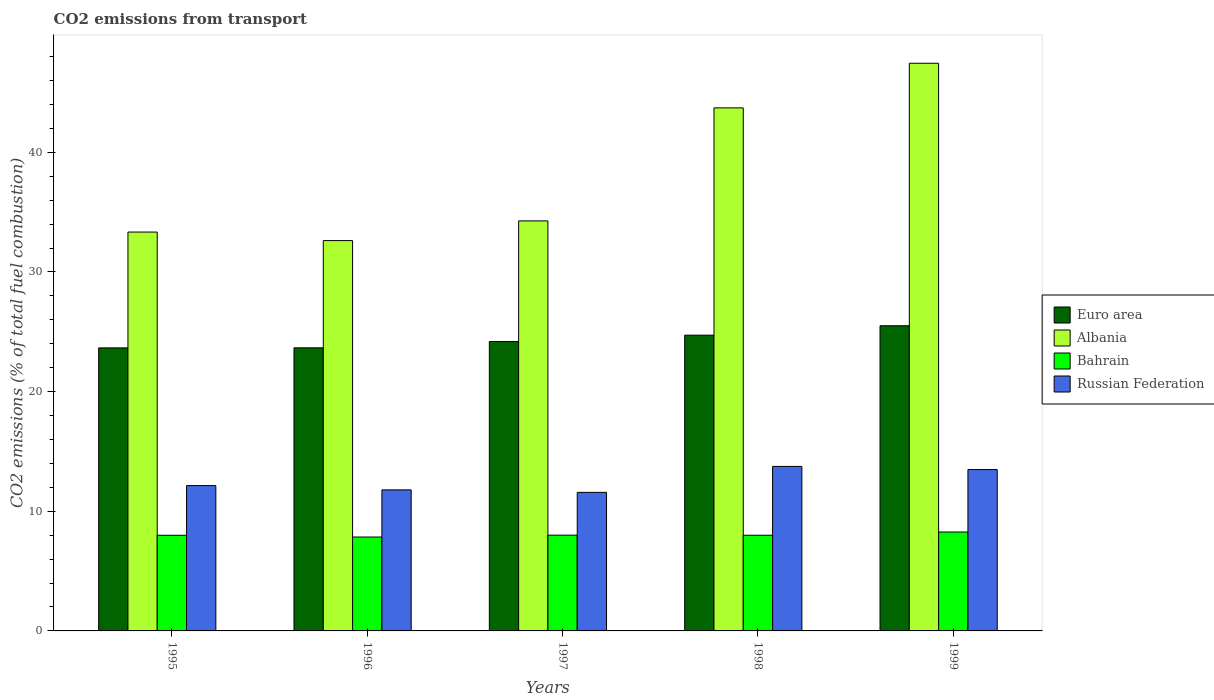How many different coloured bars are there?
Offer a terse response. 4. How many groups of bars are there?
Offer a terse response. 5. How many bars are there on the 5th tick from the left?
Ensure brevity in your answer.  4. What is the total CO2 emitted in Albania in 1997?
Keep it short and to the point. 34.27. Across all years, what is the maximum total CO2 emitted in Albania?
Your answer should be compact. 47.44. Across all years, what is the minimum total CO2 emitted in Bahrain?
Offer a terse response. 7.85. In which year was the total CO2 emitted in Albania maximum?
Keep it short and to the point. 1999. In which year was the total CO2 emitted in Bahrain minimum?
Offer a terse response. 1996. What is the total total CO2 emitted in Euro area in the graph?
Offer a very short reply. 121.72. What is the difference between the total CO2 emitted in Albania in 1996 and that in 1998?
Offer a terse response. -11.09. What is the difference between the total CO2 emitted in Euro area in 1997 and the total CO2 emitted in Russian Federation in 1995?
Keep it short and to the point. 12.04. What is the average total CO2 emitted in Russian Federation per year?
Keep it short and to the point. 12.55. In the year 1998, what is the difference between the total CO2 emitted in Euro area and total CO2 emitted in Russian Federation?
Your answer should be compact. 10.97. What is the ratio of the total CO2 emitted in Bahrain in 1997 to that in 1998?
Offer a very short reply. 1. Is the difference between the total CO2 emitted in Euro area in 1997 and 1999 greater than the difference between the total CO2 emitted in Russian Federation in 1997 and 1999?
Give a very brief answer. Yes. What is the difference between the highest and the second highest total CO2 emitted in Bahrain?
Your answer should be compact. 0.26. What is the difference between the highest and the lowest total CO2 emitted in Albania?
Keep it short and to the point. 14.82. In how many years, is the total CO2 emitted in Russian Federation greater than the average total CO2 emitted in Russian Federation taken over all years?
Offer a terse response. 2. Is the sum of the total CO2 emitted in Bahrain in 1996 and 1997 greater than the maximum total CO2 emitted in Albania across all years?
Give a very brief answer. No. What does the 1st bar from the left in 1998 represents?
Offer a terse response. Euro area. Is it the case that in every year, the sum of the total CO2 emitted in Bahrain and total CO2 emitted in Euro area is greater than the total CO2 emitted in Russian Federation?
Keep it short and to the point. Yes. How many bars are there?
Your response must be concise. 20. Are all the bars in the graph horizontal?
Provide a succinct answer. No. Does the graph contain grids?
Ensure brevity in your answer.  No. Where does the legend appear in the graph?
Ensure brevity in your answer.  Center right. How many legend labels are there?
Provide a short and direct response. 4. How are the legend labels stacked?
Give a very brief answer. Vertical. What is the title of the graph?
Your answer should be very brief. CO2 emissions from transport. Does "French Polynesia" appear as one of the legend labels in the graph?
Make the answer very short. No. What is the label or title of the Y-axis?
Offer a terse response. CO2 emissions (% of total fuel combustion). What is the CO2 emissions (% of total fuel combustion) in Euro area in 1995?
Make the answer very short. 23.65. What is the CO2 emissions (% of total fuel combustion) in Albania in 1995?
Your answer should be very brief. 33.33. What is the CO2 emissions (% of total fuel combustion) in Bahrain in 1995?
Your answer should be compact. 7.99. What is the CO2 emissions (% of total fuel combustion) in Russian Federation in 1995?
Your answer should be compact. 12.15. What is the CO2 emissions (% of total fuel combustion) of Euro area in 1996?
Provide a short and direct response. 23.66. What is the CO2 emissions (% of total fuel combustion) in Albania in 1996?
Keep it short and to the point. 32.62. What is the CO2 emissions (% of total fuel combustion) of Bahrain in 1996?
Offer a terse response. 7.85. What is the CO2 emissions (% of total fuel combustion) of Russian Federation in 1996?
Offer a terse response. 11.79. What is the CO2 emissions (% of total fuel combustion) of Euro area in 1997?
Give a very brief answer. 24.19. What is the CO2 emissions (% of total fuel combustion) in Albania in 1997?
Your answer should be compact. 34.27. What is the CO2 emissions (% of total fuel combustion) of Bahrain in 1997?
Provide a short and direct response. 8. What is the CO2 emissions (% of total fuel combustion) in Russian Federation in 1997?
Provide a short and direct response. 11.58. What is the CO2 emissions (% of total fuel combustion) of Euro area in 1998?
Provide a succinct answer. 24.72. What is the CO2 emissions (% of total fuel combustion) in Albania in 1998?
Your answer should be very brief. 43.71. What is the CO2 emissions (% of total fuel combustion) of Bahrain in 1998?
Your answer should be compact. 8. What is the CO2 emissions (% of total fuel combustion) in Russian Federation in 1998?
Keep it short and to the point. 13.75. What is the CO2 emissions (% of total fuel combustion) of Euro area in 1999?
Offer a very short reply. 25.5. What is the CO2 emissions (% of total fuel combustion) in Albania in 1999?
Provide a succinct answer. 47.44. What is the CO2 emissions (% of total fuel combustion) of Bahrain in 1999?
Make the answer very short. 8.27. What is the CO2 emissions (% of total fuel combustion) of Russian Federation in 1999?
Provide a succinct answer. 13.49. Across all years, what is the maximum CO2 emissions (% of total fuel combustion) of Euro area?
Provide a succinct answer. 25.5. Across all years, what is the maximum CO2 emissions (% of total fuel combustion) in Albania?
Give a very brief answer. 47.44. Across all years, what is the maximum CO2 emissions (% of total fuel combustion) in Bahrain?
Give a very brief answer. 8.27. Across all years, what is the maximum CO2 emissions (% of total fuel combustion) of Russian Federation?
Keep it short and to the point. 13.75. Across all years, what is the minimum CO2 emissions (% of total fuel combustion) in Euro area?
Your response must be concise. 23.65. Across all years, what is the minimum CO2 emissions (% of total fuel combustion) of Albania?
Offer a very short reply. 32.62. Across all years, what is the minimum CO2 emissions (% of total fuel combustion) in Bahrain?
Keep it short and to the point. 7.85. Across all years, what is the minimum CO2 emissions (% of total fuel combustion) of Russian Federation?
Your answer should be very brief. 11.58. What is the total CO2 emissions (% of total fuel combustion) in Euro area in the graph?
Your answer should be very brief. 121.72. What is the total CO2 emissions (% of total fuel combustion) of Albania in the graph?
Give a very brief answer. 191.37. What is the total CO2 emissions (% of total fuel combustion) of Bahrain in the graph?
Offer a very short reply. 40.1. What is the total CO2 emissions (% of total fuel combustion) of Russian Federation in the graph?
Provide a short and direct response. 62.75. What is the difference between the CO2 emissions (% of total fuel combustion) in Euro area in 1995 and that in 1996?
Ensure brevity in your answer.  -0.01. What is the difference between the CO2 emissions (% of total fuel combustion) of Albania in 1995 and that in 1996?
Offer a very short reply. 0.71. What is the difference between the CO2 emissions (% of total fuel combustion) of Bahrain in 1995 and that in 1996?
Offer a very short reply. 0.15. What is the difference between the CO2 emissions (% of total fuel combustion) of Russian Federation in 1995 and that in 1996?
Your answer should be very brief. 0.36. What is the difference between the CO2 emissions (% of total fuel combustion) in Euro area in 1995 and that in 1997?
Offer a terse response. -0.53. What is the difference between the CO2 emissions (% of total fuel combustion) of Albania in 1995 and that in 1997?
Offer a very short reply. -0.93. What is the difference between the CO2 emissions (% of total fuel combustion) in Bahrain in 1995 and that in 1997?
Provide a short and direct response. -0.01. What is the difference between the CO2 emissions (% of total fuel combustion) of Russian Federation in 1995 and that in 1997?
Give a very brief answer. 0.57. What is the difference between the CO2 emissions (% of total fuel combustion) in Euro area in 1995 and that in 1998?
Offer a very short reply. -1.06. What is the difference between the CO2 emissions (% of total fuel combustion) in Albania in 1995 and that in 1998?
Your response must be concise. -10.38. What is the difference between the CO2 emissions (% of total fuel combustion) in Bahrain in 1995 and that in 1998?
Give a very brief answer. -0. What is the difference between the CO2 emissions (% of total fuel combustion) of Russian Federation in 1995 and that in 1998?
Your response must be concise. -1.6. What is the difference between the CO2 emissions (% of total fuel combustion) of Euro area in 1995 and that in 1999?
Keep it short and to the point. -1.85. What is the difference between the CO2 emissions (% of total fuel combustion) of Albania in 1995 and that in 1999?
Your answer should be very brief. -14.11. What is the difference between the CO2 emissions (% of total fuel combustion) of Bahrain in 1995 and that in 1999?
Give a very brief answer. -0.27. What is the difference between the CO2 emissions (% of total fuel combustion) of Russian Federation in 1995 and that in 1999?
Keep it short and to the point. -1.34. What is the difference between the CO2 emissions (% of total fuel combustion) of Euro area in 1996 and that in 1997?
Keep it short and to the point. -0.53. What is the difference between the CO2 emissions (% of total fuel combustion) in Albania in 1996 and that in 1997?
Your response must be concise. -1.65. What is the difference between the CO2 emissions (% of total fuel combustion) of Bahrain in 1996 and that in 1997?
Ensure brevity in your answer.  -0.16. What is the difference between the CO2 emissions (% of total fuel combustion) of Russian Federation in 1996 and that in 1997?
Provide a short and direct response. 0.21. What is the difference between the CO2 emissions (% of total fuel combustion) in Euro area in 1996 and that in 1998?
Ensure brevity in your answer.  -1.06. What is the difference between the CO2 emissions (% of total fuel combustion) in Albania in 1996 and that in 1998?
Your response must be concise. -11.09. What is the difference between the CO2 emissions (% of total fuel combustion) of Bahrain in 1996 and that in 1998?
Keep it short and to the point. -0.15. What is the difference between the CO2 emissions (% of total fuel combustion) of Russian Federation in 1996 and that in 1998?
Offer a terse response. -1.96. What is the difference between the CO2 emissions (% of total fuel combustion) in Euro area in 1996 and that in 1999?
Offer a very short reply. -1.84. What is the difference between the CO2 emissions (% of total fuel combustion) in Albania in 1996 and that in 1999?
Offer a terse response. -14.82. What is the difference between the CO2 emissions (% of total fuel combustion) in Bahrain in 1996 and that in 1999?
Offer a terse response. -0.42. What is the difference between the CO2 emissions (% of total fuel combustion) in Russian Federation in 1996 and that in 1999?
Offer a terse response. -1.7. What is the difference between the CO2 emissions (% of total fuel combustion) of Euro area in 1997 and that in 1998?
Ensure brevity in your answer.  -0.53. What is the difference between the CO2 emissions (% of total fuel combustion) of Albania in 1997 and that in 1998?
Keep it short and to the point. -9.45. What is the difference between the CO2 emissions (% of total fuel combustion) in Bahrain in 1997 and that in 1998?
Offer a very short reply. 0.01. What is the difference between the CO2 emissions (% of total fuel combustion) in Russian Federation in 1997 and that in 1998?
Your answer should be compact. -2.17. What is the difference between the CO2 emissions (% of total fuel combustion) in Euro area in 1997 and that in 1999?
Your answer should be compact. -1.32. What is the difference between the CO2 emissions (% of total fuel combustion) of Albania in 1997 and that in 1999?
Offer a terse response. -13.17. What is the difference between the CO2 emissions (% of total fuel combustion) in Bahrain in 1997 and that in 1999?
Provide a short and direct response. -0.26. What is the difference between the CO2 emissions (% of total fuel combustion) in Russian Federation in 1997 and that in 1999?
Your answer should be compact. -1.91. What is the difference between the CO2 emissions (% of total fuel combustion) of Euro area in 1998 and that in 1999?
Provide a succinct answer. -0.79. What is the difference between the CO2 emissions (% of total fuel combustion) in Albania in 1998 and that in 1999?
Keep it short and to the point. -3.73. What is the difference between the CO2 emissions (% of total fuel combustion) in Bahrain in 1998 and that in 1999?
Your answer should be very brief. -0.27. What is the difference between the CO2 emissions (% of total fuel combustion) in Russian Federation in 1998 and that in 1999?
Give a very brief answer. 0.26. What is the difference between the CO2 emissions (% of total fuel combustion) of Euro area in 1995 and the CO2 emissions (% of total fuel combustion) of Albania in 1996?
Keep it short and to the point. -8.97. What is the difference between the CO2 emissions (% of total fuel combustion) of Euro area in 1995 and the CO2 emissions (% of total fuel combustion) of Bahrain in 1996?
Ensure brevity in your answer.  15.81. What is the difference between the CO2 emissions (% of total fuel combustion) in Euro area in 1995 and the CO2 emissions (% of total fuel combustion) in Russian Federation in 1996?
Ensure brevity in your answer.  11.87. What is the difference between the CO2 emissions (% of total fuel combustion) of Albania in 1995 and the CO2 emissions (% of total fuel combustion) of Bahrain in 1996?
Your answer should be compact. 25.49. What is the difference between the CO2 emissions (% of total fuel combustion) of Albania in 1995 and the CO2 emissions (% of total fuel combustion) of Russian Federation in 1996?
Provide a short and direct response. 21.55. What is the difference between the CO2 emissions (% of total fuel combustion) of Bahrain in 1995 and the CO2 emissions (% of total fuel combustion) of Russian Federation in 1996?
Your answer should be very brief. -3.79. What is the difference between the CO2 emissions (% of total fuel combustion) in Euro area in 1995 and the CO2 emissions (% of total fuel combustion) in Albania in 1997?
Keep it short and to the point. -10.61. What is the difference between the CO2 emissions (% of total fuel combustion) of Euro area in 1995 and the CO2 emissions (% of total fuel combustion) of Bahrain in 1997?
Offer a terse response. 15.65. What is the difference between the CO2 emissions (% of total fuel combustion) of Euro area in 1995 and the CO2 emissions (% of total fuel combustion) of Russian Federation in 1997?
Offer a very short reply. 12.08. What is the difference between the CO2 emissions (% of total fuel combustion) of Albania in 1995 and the CO2 emissions (% of total fuel combustion) of Bahrain in 1997?
Provide a succinct answer. 25.33. What is the difference between the CO2 emissions (% of total fuel combustion) in Albania in 1995 and the CO2 emissions (% of total fuel combustion) in Russian Federation in 1997?
Offer a very short reply. 21.75. What is the difference between the CO2 emissions (% of total fuel combustion) in Bahrain in 1995 and the CO2 emissions (% of total fuel combustion) in Russian Federation in 1997?
Offer a terse response. -3.59. What is the difference between the CO2 emissions (% of total fuel combustion) of Euro area in 1995 and the CO2 emissions (% of total fuel combustion) of Albania in 1998?
Offer a terse response. -20.06. What is the difference between the CO2 emissions (% of total fuel combustion) of Euro area in 1995 and the CO2 emissions (% of total fuel combustion) of Bahrain in 1998?
Provide a short and direct response. 15.66. What is the difference between the CO2 emissions (% of total fuel combustion) in Euro area in 1995 and the CO2 emissions (% of total fuel combustion) in Russian Federation in 1998?
Keep it short and to the point. 9.91. What is the difference between the CO2 emissions (% of total fuel combustion) of Albania in 1995 and the CO2 emissions (% of total fuel combustion) of Bahrain in 1998?
Provide a succinct answer. 25.34. What is the difference between the CO2 emissions (% of total fuel combustion) in Albania in 1995 and the CO2 emissions (% of total fuel combustion) in Russian Federation in 1998?
Your response must be concise. 19.58. What is the difference between the CO2 emissions (% of total fuel combustion) in Bahrain in 1995 and the CO2 emissions (% of total fuel combustion) in Russian Federation in 1998?
Your response must be concise. -5.76. What is the difference between the CO2 emissions (% of total fuel combustion) in Euro area in 1995 and the CO2 emissions (% of total fuel combustion) in Albania in 1999?
Offer a very short reply. -23.79. What is the difference between the CO2 emissions (% of total fuel combustion) in Euro area in 1995 and the CO2 emissions (% of total fuel combustion) in Bahrain in 1999?
Make the answer very short. 15.39. What is the difference between the CO2 emissions (% of total fuel combustion) in Euro area in 1995 and the CO2 emissions (% of total fuel combustion) in Russian Federation in 1999?
Keep it short and to the point. 10.17. What is the difference between the CO2 emissions (% of total fuel combustion) in Albania in 1995 and the CO2 emissions (% of total fuel combustion) in Bahrain in 1999?
Provide a succinct answer. 25.07. What is the difference between the CO2 emissions (% of total fuel combustion) of Albania in 1995 and the CO2 emissions (% of total fuel combustion) of Russian Federation in 1999?
Your response must be concise. 19.85. What is the difference between the CO2 emissions (% of total fuel combustion) of Bahrain in 1995 and the CO2 emissions (% of total fuel combustion) of Russian Federation in 1999?
Ensure brevity in your answer.  -5.49. What is the difference between the CO2 emissions (% of total fuel combustion) of Euro area in 1996 and the CO2 emissions (% of total fuel combustion) of Albania in 1997?
Give a very brief answer. -10.61. What is the difference between the CO2 emissions (% of total fuel combustion) in Euro area in 1996 and the CO2 emissions (% of total fuel combustion) in Bahrain in 1997?
Keep it short and to the point. 15.66. What is the difference between the CO2 emissions (% of total fuel combustion) in Euro area in 1996 and the CO2 emissions (% of total fuel combustion) in Russian Federation in 1997?
Ensure brevity in your answer.  12.08. What is the difference between the CO2 emissions (% of total fuel combustion) of Albania in 1996 and the CO2 emissions (% of total fuel combustion) of Bahrain in 1997?
Provide a succinct answer. 24.62. What is the difference between the CO2 emissions (% of total fuel combustion) in Albania in 1996 and the CO2 emissions (% of total fuel combustion) in Russian Federation in 1997?
Offer a terse response. 21.04. What is the difference between the CO2 emissions (% of total fuel combustion) of Bahrain in 1996 and the CO2 emissions (% of total fuel combustion) of Russian Federation in 1997?
Offer a terse response. -3.73. What is the difference between the CO2 emissions (% of total fuel combustion) in Euro area in 1996 and the CO2 emissions (% of total fuel combustion) in Albania in 1998?
Offer a terse response. -20.05. What is the difference between the CO2 emissions (% of total fuel combustion) of Euro area in 1996 and the CO2 emissions (% of total fuel combustion) of Bahrain in 1998?
Make the answer very short. 15.66. What is the difference between the CO2 emissions (% of total fuel combustion) in Euro area in 1996 and the CO2 emissions (% of total fuel combustion) in Russian Federation in 1998?
Your response must be concise. 9.91. What is the difference between the CO2 emissions (% of total fuel combustion) of Albania in 1996 and the CO2 emissions (% of total fuel combustion) of Bahrain in 1998?
Offer a terse response. 24.62. What is the difference between the CO2 emissions (% of total fuel combustion) of Albania in 1996 and the CO2 emissions (% of total fuel combustion) of Russian Federation in 1998?
Provide a succinct answer. 18.87. What is the difference between the CO2 emissions (% of total fuel combustion) of Bahrain in 1996 and the CO2 emissions (% of total fuel combustion) of Russian Federation in 1998?
Make the answer very short. -5.9. What is the difference between the CO2 emissions (% of total fuel combustion) in Euro area in 1996 and the CO2 emissions (% of total fuel combustion) in Albania in 1999?
Make the answer very short. -23.78. What is the difference between the CO2 emissions (% of total fuel combustion) in Euro area in 1996 and the CO2 emissions (% of total fuel combustion) in Bahrain in 1999?
Give a very brief answer. 15.39. What is the difference between the CO2 emissions (% of total fuel combustion) of Euro area in 1996 and the CO2 emissions (% of total fuel combustion) of Russian Federation in 1999?
Provide a succinct answer. 10.17. What is the difference between the CO2 emissions (% of total fuel combustion) of Albania in 1996 and the CO2 emissions (% of total fuel combustion) of Bahrain in 1999?
Give a very brief answer. 24.35. What is the difference between the CO2 emissions (% of total fuel combustion) in Albania in 1996 and the CO2 emissions (% of total fuel combustion) in Russian Federation in 1999?
Make the answer very short. 19.13. What is the difference between the CO2 emissions (% of total fuel combustion) in Bahrain in 1996 and the CO2 emissions (% of total fuel combustion) in Russian Federation in 1999?
Your response must be concise. -5.64. What is the difference between the CO2 emissions (% of total fuel combustion) of Euro area in 1997 and the CO2 emissions (% of total fuel combustion) of Albania in 1998?
Your answer should be compact. -19.53. What is the difference between the CO2 emissions (% of total fuel combustion) in Euro area in 1997 and the CO2 emissions (% of total fuel combustion) in Bahrain in 1998?
Offer a very short reply. 16.19. What is the difference between the CO2 emissions (% of total fuel combustion) of Euro area in 1997 and the CO2 emissions (% of total fuel combustion) of Russian Federation in 1998?
Your response must be concise. 10.44. What is the difference between the CO2 emissions (% of total fuel combustion) in Albania in 1997 and the CO2 emissions (% of total fuel combustion) in Bahrain in 1998?
Your answer should be compact. 26.27. What is the difference between the CO2 emissions (% of total fuel combustion) of Albania in 1997 and the CO2 emissions (% of total fuel combustion) of Russian Federation in 1998?
Provide a short and direct response. 20.52. What is the difference between the CO2 emissions (% of total fuel combustion) of Bahrain in 1997 and the CO2 emissions (% of total fuel combustion) of Russian Federation in 1998?
Your answer should be compact. -5.75. What is the difference between the CO2 emissions (% of total fuel combustion) in Euro area in 1997 and the CO2 emissions (% of total fuel combustion) in Albania in 1999?
Ensure brevity in your answer.  -23.25. What is the difference between the CO2 emissions (% of total fuel combustion) in Euro area in 1997 and the CO2 emissions (% of total fuel combustion) in Bahrain in 1999?
Give a very brief answer. 15.92. What is the difference between the CO2 emissions (% of total fuel combustion) in Euro area in 1997 and the CO2 emissions (% of total fuel combustion) in Russian Federation in 1999?
Your answer should be compact. 10.7. What is the difference between the CO2 emissions (% of total fuel combustion) of Albania in 1997 and the CO2 emissions (% of total fuel combustion) of Bahrain in 1999?
Your answer should be very brief. 26. What is the difference between the CO2 emissions (% of total fuel combustion) in Albania in 1997 and the CO2 emissions (% of total fuel combustion) in Russian Federation in 1999?
Your response must be concise. 20.78. What is the difference between the CO2 emissions (% of total fuel combustion) in Bahrain in 1997 and the CO2 emissions (% of total fuel combustion) in Russian Federation in 1999?
Ensure brevity in your answer.  -5.48. What is the difference between the CO2 emissions (% of total fuel combustion) in Euro area in 1998 and the CO2 emissions (% of total fuel combustion) in Albania in 1999?
Make the answer very short. -22.72. What is the difference between the CO2 emissions (% of total fuel combustion) of Euro area in 1998 and the CO2 emissions (% of total fuel combustion) of Bahrain in 1999?
Your response must be concise. 16.45. What is the difference between the CO2 emissions (% of total fuel combustion) in Euro area in 1998 and the CO2 emissions (% of total fuel combustion) in Russian Federation in 1999?
Ensure brevity in your answer.  11.23. What is the difference between the CO2 emissions (% of total fuel combustion) in Albania in 1998 and the CO2 emissions (% of total fuel combustion) in Bahrain in 1999?
Give a very brief answer. 35.45. What is the difference between the CO2 emissions (% of total fuel combustion) in Albania in 1998 and the CO2 emissions (% of total fuel combustion) in Russian Federation in 1999?
Offer a very short reply. 30.23. What is the difference between the CO2 emissions (% of total fuel combustion) in Bahrain in 1998 and the CO2 emissions (% of total fuel combustion) in Russian Federation in 1999?
Your answer should be compact. -5.49. What is the average CO2 emissions (% of total fuel combustion) of Euro area per year?
Ensure brevity in your answer.  24.34. What is the average CO2 emissions (% of total fuel combustion) in Albania per year?
Your answer should be compact. 38.27. What is the average CO2 emissions (% of total fuel combustion) in Bahrain per year?
Make the answer very short. 8.02. What is the average CO2 emissions (% of total fuel combustion) of Russian Federation per year?
Your answer should be very brief. 12.55. In the year 1995, what is the difference between the CO2 emissions (% of total fuel combustion) of Euro area and CO2 emissions (% of total fuel combustion) of Albania?
Make the answer very short. -9.68. In the year 1995, what is the difference between the CO2 emissions (% of total fuel combustion) of Euro area and CO2 emissions (% of total fuel combustion) of Bahrain?
Your answer should be very brief. 15.66. In the year 1995, what is the difference between the CO2 emissions (% of total fuel combustion) of Euro area and CO2 emissions (% of total fuel combustion) of Russian Federation?
Keep it short and to the point. 11.51. In the year 1995, what is the difference between the CO2 emissions (% of total fuel combustion) in Albania and CO2 emissions (% of total fuel combustion) in Bahrain?
Offer a terse response. 25.34. In the year 1995, what is the difference between the CO2 emissions (% of total fuel combustion) of Albania and CO2 emissions (% of total fuel combustion) of Russian Federation?
Make the answer very short. 21.19. In the year 1995, what is the difference between the CO2 emissions (% of total fuel combustion) of Bahrain and CO2 emissions (% of total fuel combustion) of Russian Federation?
Offer a very short reply. -4.15. In the year 1996, what is the difference between the CO2 emissions (% of total fuel combustion) of Euro area and CO2 emissions (% of total fuel combustion) of Albania?
Offer a very short reply. -8.96. In the year 1996, what is the difference between the CO2 emissions (% of total fuel combustion) in Euro area and CO2 emissions (% of total fuel combustion) in Bahrain?
Ensure brevity in your answer.  15.81. In the year 1996, what is the difference between the CO2 emissions (% of total fuel combustion) in Euro area and CO2 emissions (% of total fuel combustion) in Russian Federation?
Provide a short and direct response. 11.87. In the year 1996, what is the difference between the CO2 emissions (% of total fuel combustion) in Albania and CO2 emissions (% of total fuel combustion) in Bahrain?
Your response must be concise. 24.77. In the year 1996, what is the difference between the CO2 emissions (% of total fuel combustion) of Albania and CO2 emissions (% of total fuel combustion) of Russian Federation?
Offer a terse response. 20.83. In the year 1996, what is the difference between the CO2 emissions (% of total fuel combustion) of Bahrain and CO2 emissions (% of total fuel combustion) of Russian Federation?
Ensure brevity in your answer.  -3.94. In the year 1997, what is the difference between the CO2 emissions (% of total fuel combustion) in Euro area and CO2 emissions (% of total fuel combustion) in Albania?
Give a very brief answer. -10.08. In the year 1997, what is the difference between the CO2 emissions (% of total fuel combustion) of Euro area and CO2 emissions (% of total fuel combustion) of Bahrain?
Offer a terse response. 16.18. In the year 1997, what is the difference between the CO2 emissions (% of total fuel combustion) of Euro area and CO2 emissions (% of total fuel combustion) of Russian Federation?
Make the answer very short. 12.61. In the year 1997, what is the difference between the CO2 emissions (% of total fuel combustion) in Albania and CO2 emissions (% of total fuel combustion) in Bahrain?
Offer a terse response. 26.26. In the year 1997, what is the difference between the CO2 emissions (% of total fuel combustion) in Albania and CO2 emissions (% of total fuel combustion) in Russian Federation?
Your answer should be compact. 22.69. In the year 1997, what is the difference between the CO2 emissions (% of total fuel combustion) of Bahrain and CO2 emissions (% of total fuel combustion) of Russian Federation?
Provide a succinct answer. -3.58. In the year 1998, what is the difference between the CO2 emissions (% of total fuel combustion) in Euro area and CO2 emissions (% of total fuel combustion) in Albania?
Your response must be concise. -19. In the year 1998, what is the difference between the CO2 emissions (% of total fuel combustion) in Euro area and CO2 emissions (% of total fuel combustion) in Bahrain?
Make the answer very short. 16.72. In the year 1998, what is the difference between the CO2 emissions (% of total fuel combustion) in Euro area and CO2 emissions (% of total fuel combustion) in Russian Federation?
Provide a succinct answer. 10.97. In the year 1998, what is the difference between the CO2 emissions (% of total fuel combustion) in Albania and CO2 emissions (% of total fuel combustion) in Bahrain?
Offer a terse response. 35.72. In the year 1998, what is the difference between the CO2 emissions (% of total fuel combustion) in Albania and CO2 emissions (% of total fuel combustion) in Russian Federation?
Make the answer very short. 29.96. In the year 1998, what is the difference between the CO2 emissions (% of total fuel combustion) in Bahrain and CO2 emissions (% of total fuel combustion) in Russian Federation?
Offer a terse response. -5.75. In the year 1999, what is the difference between the CO2 emissions (% of total fuel combustion) in Euro area and CO2 emissions (% of total fuel combustion) in Albania?
Provide a short and direct response. -21.94. In the year 1999, what is the difference between the CO2 emissions (% of total fuel combustion) in Euro area and CO2 emissions (% of total fuel combustion) in Bahrain?
Keep it short and to the point. 17.24. In the year 1999, what is the difference between the CO2 emissions (% of total fuel combustion) of Euro area and CO2 emissions (% of total fuel combustion) of Russian Federation?
Keep it short and to the point. 12.02. In the year 1999, what is the difference between the CO2 emissions (% of total fuel combustion) in Albania and CO2 emissions (% of total fuel combustion) in Bahrain?
Your answer should be compact. 39.17. In the year 1999, what is the difference between the CO2 emissions (% of total fuel combustion) of Albania and CO2 emissions (% of total fuel combustion) of Russian Federation?
Make the answer very short. 33.95. In the year 1999, what is the difference between the CO2 emissions (% of total fuel combustion) of Bahrain and CO2 emissions (% of total fuel combustion) of Russian Federation?
Ensure brevity in your answer.  -5.22. What is the ratio of the CO2 emissions (% of total fuel combustion) of Albania in 1995 to that in 1996?
Ensure brevity in your answer.  1.02. What is the ratio of the CO2 emissions (% of total fuel combustion) in Bahrain in 1995 to that in 1996?
Offer a very short reply. 1.02. What is the ratio of the CO2 emissions (% of total fuel combustion) of Russian Federation in 1995 to that in 1996?
Offer a terse response. 1.03. What is the ratio of the CO2 emissions (% of total fuel combustion) of Euro area in 1995 to that in 1997?
Keep it short and to the point. 0.98. What is the ratio of the CO2 emissions (% of total fuel combustion) of Albania in 1995 to that in 1997?
Make the answer very short. 0.97. What is the ratio of the CO2 emissions (% of total fuel combustion) in Bahrain in 1995 to that in 1997?
Give a very brief answer. 1. What is the ratio of the CO2 emissions (% of total fuel combustion) of Russian Federation in 1995 to that in 1997?
Provide a succinct answer. 1.05. What is the ratio of the CO2 emissions (% of total fuel combustion) in Euro area in 1995 to that in 1998?
Ensure brevity in your answer.  0.96. What is the ratio of the CO2 emissions (% of total fuel combustion) of Albania in 1995 to that in 1998?
Provide a short and direct response. 0.76. What is the ratio of the CO2 emissions (% of total fuel combustion) of Bahrain in 1995 to that in 1998?
Offer a terse response. 1. What is the ratio of the CO2 emissions (% of total fuel combustion) of Russian Federation in 1995 to that in 1998?
Make the answer very short. 0.88. What is the ratio of the CO2 emissions (% of total fuel combustion) of Euro area in 1995 to that in 1999?
Offer a terse response. 0.93. What is the ratio of the CO2 emissions (% of total fuel combustion) of Albania in 1995 to that in 1999?
Your answer should be very brief. 0.7. What is the ratio of the CO2 emissions (% of total fuel combustion) in Bahrain in 1995 to that in 1999?
Provide a short and direct response. 0.97. What is the ratio of the CO2 emissions (% of total fuel combustion) of Russian Federation in 1995 to that in 1999?
Give a very brief answer. 0.9. What is the ratio of the CO2 emissions (% of total fuel combustion) of Euro area in 1996 to that in 1997?
Offer a very short reply. 0.98. What is the ratio of the CO2 emissions (% of total fuel combustion) of Albania in 1996 to that in 1997?
Make the answer very short. 0.95. What is the ratio of the CO2 emissions (% of total fuel combustion) in Bahrain in 1996 to that in 1997?
Your answer should be compact. 0.98. What is the ratio of the CO2 emissions (% of total fuel combustion) of Euro area in 1996 to that in 1998?
Provide a succinct answer. 0.96. What is the ratio of the CO2 emissions (% of total fuel combustion) in Albania in 1996 to that in 1998?
Provide a short and direct response. 0.75. What is the ratio of the CO2 emissions (% of total fuel combustion) of Bahrain in 1996 to that in 1998?
Provide a short and direct response. 0.98. What is the ratio of the CO2 emissions (% of total fuel combustion) of Russian Federation in 1996 to that in 1998?
Your answer should be compact. 0.86. What is the ratio of the CO2 emissions (% of total fuel combustion) of Euro area in 1996 to that in 1999?
Offer a very short reply. 0.93. What is the ratio of the CO2 emissions (% of total fuel combustion) in Albania in 1996 to that in 1999?
Make the answer very short. 0.69. What is the ratio of the CO2 emissions (% of total fuel combustion) in Bahrain in 1996 to that in 1999?
Your answer should be compact. 0.95. What is the ratio of the CO2 emissions (% of total fuel combustion) in Russian Federation in 1996 to that in 1999?
Your response must be concise. 0.87. What is the ratio of the CO2 emissions (% of total fuel combustion) of Euro area in 1997 to that in 1998?
Your answer should be very brief. 0.98. What is the ratio of the CO2 emissions (% of total fuel combustion) in Albania in 1997 to that in 1998?
Keep it short and to the point. 0.78. What is the ratio of the CO2 emissions (% of total fuel combustion) of Russian Federation in 1997 to that in 1998?
Ensure brevity in your answer.  0.84. What is the ratio of the CO2 emissions (% of total fuel combustion) of Euro area in 1997 to that in 1999?
Keep it short and to the point. 0.95. What is the ratio of the CO2 emissions (% of total fuel combustion) of Albania in 1997 to that in 1999?
Offer a terse response. 0.72. What is the ratio of the CO2 emissions (% of total fuel combustion) in Bahrain in 1997 to that in 1999?
Offer a terse response. 0.97. What is the ratio of the CO2 emissions (% of total fuel combustion) in Russian Federation in 1997 to that in 1999?
Offer a terse response. 0.86. What is the ratio of the CO2 emissions (% of total fuel combustion) in Euro area in 1998 to that in 1999?
Offer a terse response. 0.97. What is the ratio of the CO2 emissions (% of total fuel combustion) in Albania in 1998 to that in 1999?
Your answer should be very brief. 0.92. What is the ratio of the CO2 emissions (% of total fuel combustion) of Bahrain in 1998 to that in 1999?
Your answer should be very brief. 0.97. What is the ratio of the CO2 emissions (% of total fuel combustion) in Russian Federation in 1998 to that in 1999?
Offer a terse response. 1.02. What is the difference between the highest and the second highest CO2 emissions (% of total fuel combustion) in Euro area?
Ensure brevity in your answer.  0.79. What is the difference between the highest and the second highest CO2 emissions (% of total fuel combustion) in Albania?
Provide a short and direct response. 3.73. What is the difference between the highest and the second highest CO2 emissions (% of total fuel combustion) of Bahrain?
Provide a short and direct response. 0.26. What is the difference between the highest and the second highest CO2 emissions (% of total fuel combustion) of Russian Federation?
Ensure brevity in your answer.  0.26. What is the difference between the highest and the lowest CO2 emissions (% of total fuel combustion) of Euro area?
Your answer should be very brief. 1.85. What is the difference between the highest and the lowest CO2 emissions (% of total fuel combustion) in Albania?
Give a very brief answer. 14.82. What is the difference between the highest and the lowest CO2 emissions (% of total fuel combustion) of Bahrain?
Provide a succinct answer. 0.42. What is the difference between the highest and the lowest CO2 emissions (% of total fuel combustion) in Russian Federation?
Provide a succinct answer. 2.17. 